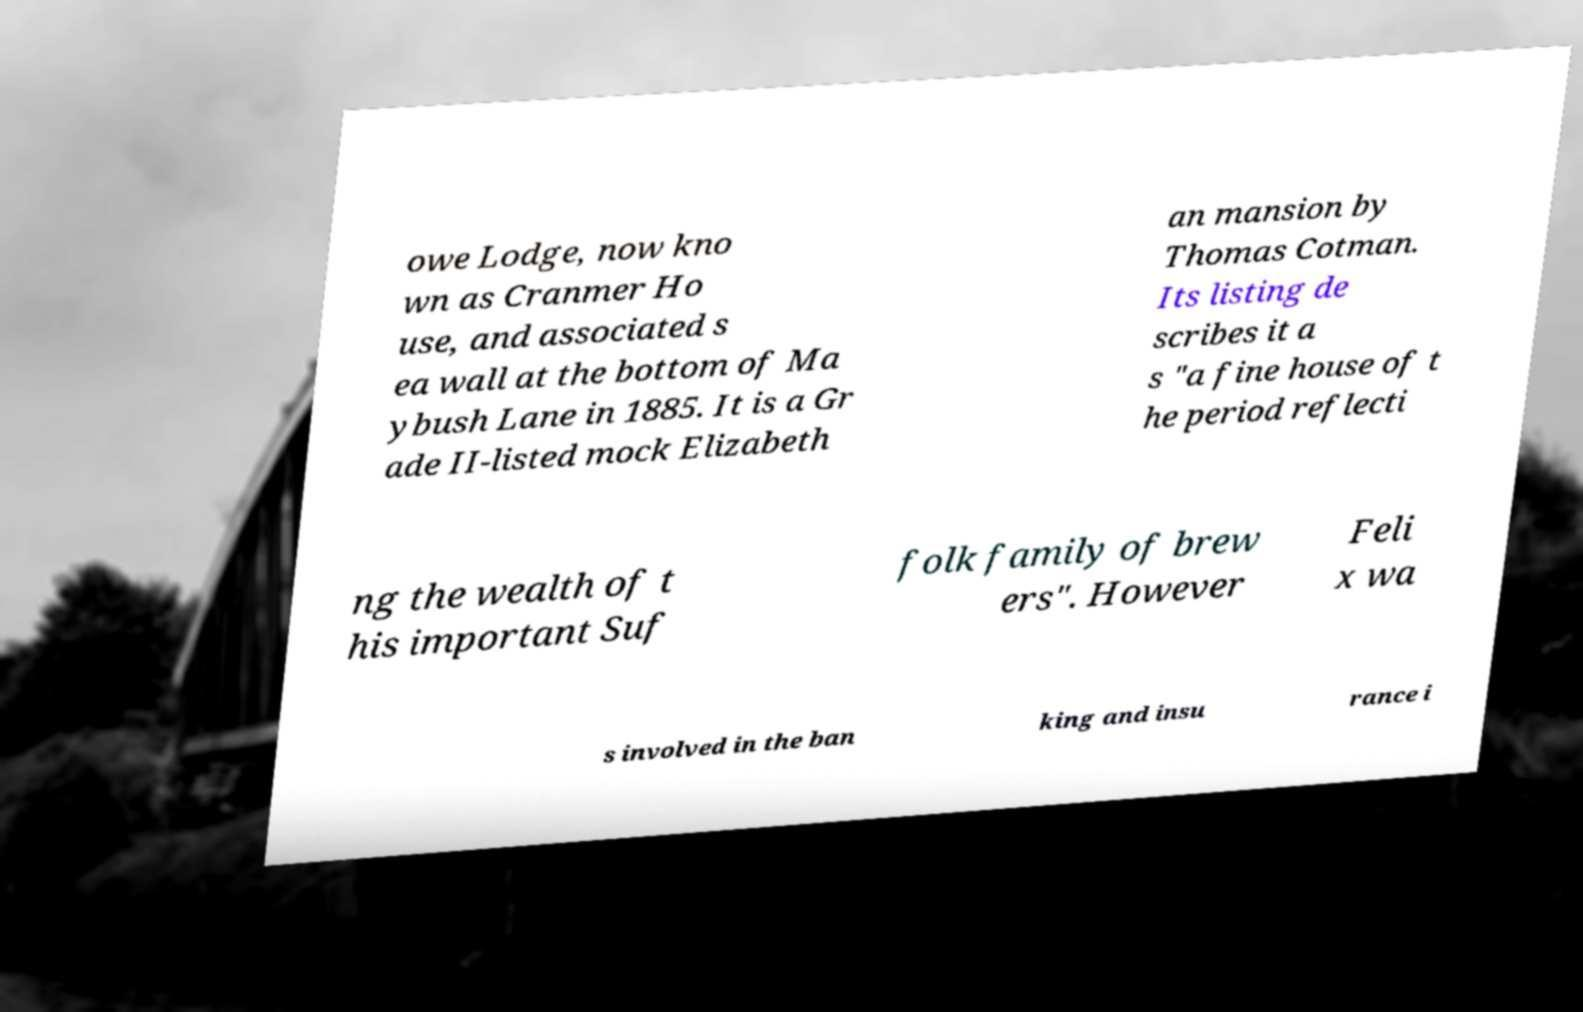Could you assist in decoding the text presented in this image and type it out clearly? owe Lodge, now kno wn as Cranmer Ho use, and associated s ea wall at the bottom of Ma ybush Lane in 1885. It is a Gr ade II-listed mock Elizabeth an mansion by Thomas Cotman. Its listing de scribes it a s "a fine house of t he period reflecti ng the wealth of t his important Suf folk family of brew ers". However Feli x wa s involved in the ban king and insu rance i 